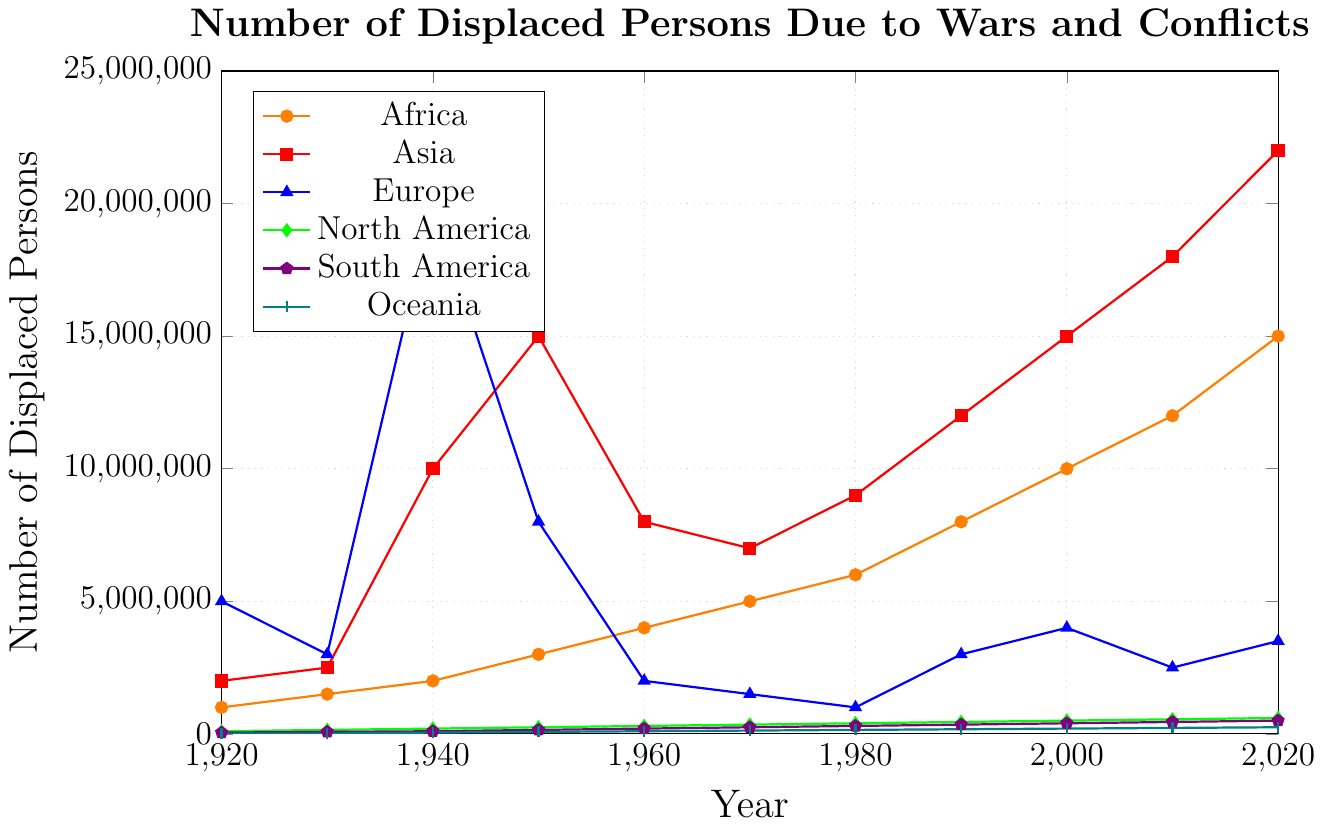What is the trend of displaced persons in Africa from 1920 to 2020? The visual trend can be observed by analyzing the line for Africa (orange). It starts at 1,000,000 in 1920 and increases continuously, reaching 15,000,000 in 2020. This demonstrates an upward trend throughout the century.
Answer: Upward trend Which continent had the highest number of displaced persons in 1940? By comparing the data points for each continent in the year 1940, the highest value can be seen for Europe (blue) with 20,000,000 displaced persons.
Answer: Europe How many continents had higher displaced persons than North America in 2020? List them. The value for North America (green) in 2020 is 600,000. By comparing this to the other continents, Africa, Asia, Europe, South America, and Oceania all have higher values. This gives us 5 continents.
Answer: 5, Africa, Asia, Europe, South America, Oceania What is the total number of displaced persons in 1960 across all continents? Summing up the 1960 values for all continents: Africa (4,000,000) + Asia (8,000,000) + Europe (2,000,000) + North America (300,000) + South America (200,000) + Oceania (100,000). Total = 4,000,000 + 8,000,000 + 2,000,000 + 300,000 + 200,000 + 100,000 = 14,600,000.
Answer: 14,600,000 Which decade saw the highest increase in displaced persons in Asia? By examining the values for Asia: the values in 1950 (15,000,000) and 1940 (10,000,000) show an increase of 5,000,000, which is the highest compared to changes in other decades.
Answer: 1940 to 1950 In which year did Europe have the lowest number of displaced persons? By observing the blue line for Europe, the lowest value is around 1,000,000 in 1980.
Answer: 1980 Between which two decades did Africa see the greatest rise in the number of displaced persons? By comparing the differences for Africa: the greatest rise is between 2010 (12,000,000) and 2020 (15,000,000) which is an increase of 3,000,000.
Answer: 2010 to 2020 Compare the number of displaced persons in South America to Oceania in 1950. Which is higher and by how much? South America's number in 1950 is 150,000 and Oceania's is 75,000. The difference is 150,000 - 75,000 = 75,000. South America has more displaced persons by 75,000.
Answer: South America by 75,000 